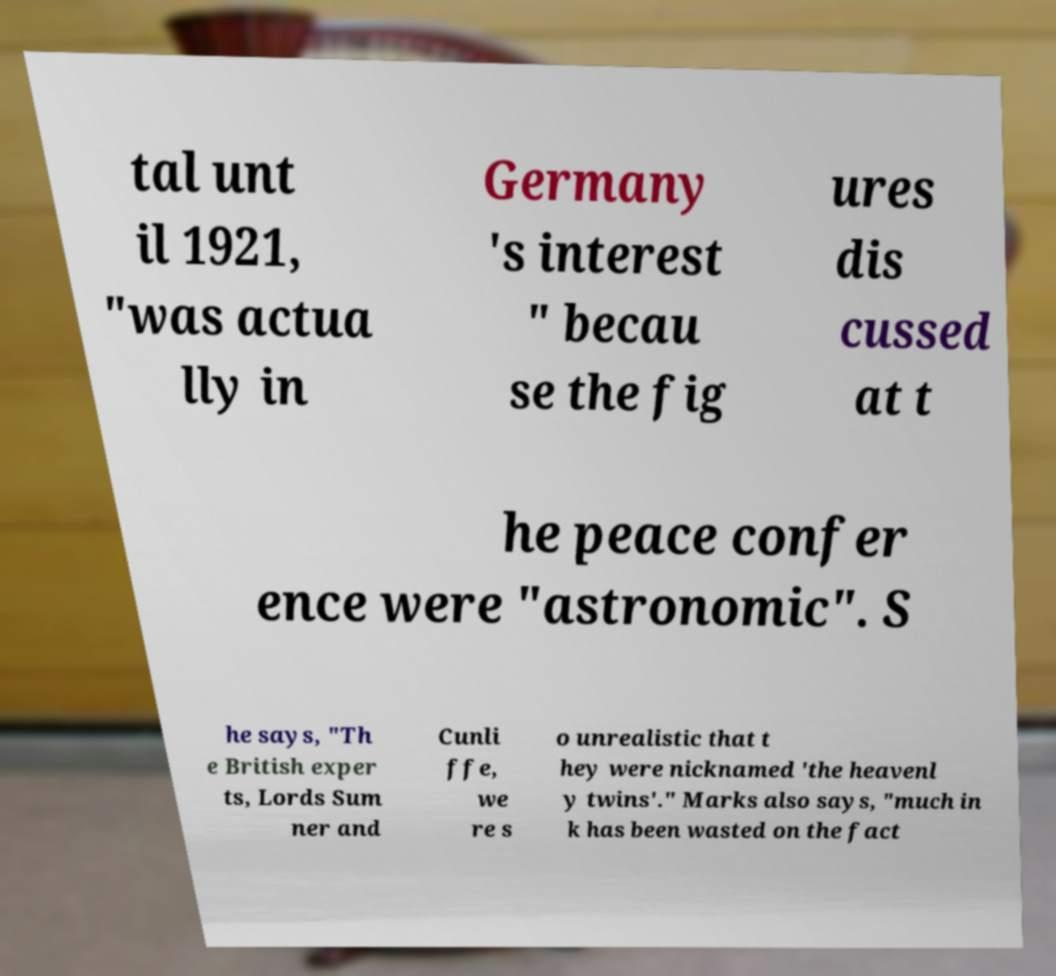Please identify and transcribe the text found in this image. tal unt il 1921, "was actua lly in Germany 's interest " becau se the fig ures dis cussed at t he peace confer ence were "astronomic". S he says, "Th e British exper ts, Lords Sum ner and Cunli ffe, we re s o unrealistic that t hey were nicknamed 'the heavenl y twins'." Marks also says, "much in k has been wasted on the fact 